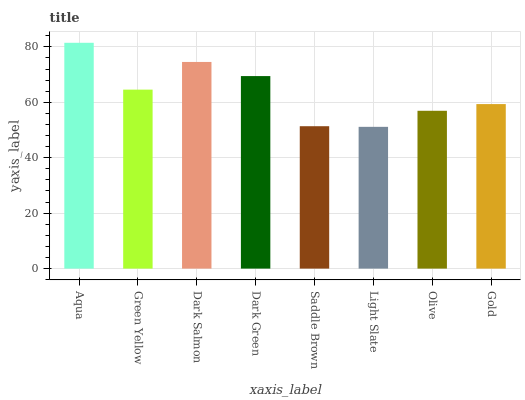Is Green Yellow the minimum?
Answer yes or no. No. Is Green Yellow the maximum?
Answer yes or no. No. Is Aqua greater than Green Yellow?
Answer yes or no. Yes. Is Green Yellow less than Aqua?
Answer yes or no. Yes. Is Green Yellow greater than Aqua?
Answer yes or no. No. Is Aqua less than Green Yellow?
Answer yes or no. No. Is Green Yellow the high median?
Answer yes or no. Yes. Is Gold the low median?
Answer yes or no. Yes. Is Olive the high median?
Answer yes or no. No. Is Green Yellow the low median?
Answer yes or no. No. 